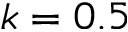<formula> <loc_0><loc_0><loc_500><loc_500>k = 0 . 5</formula> 